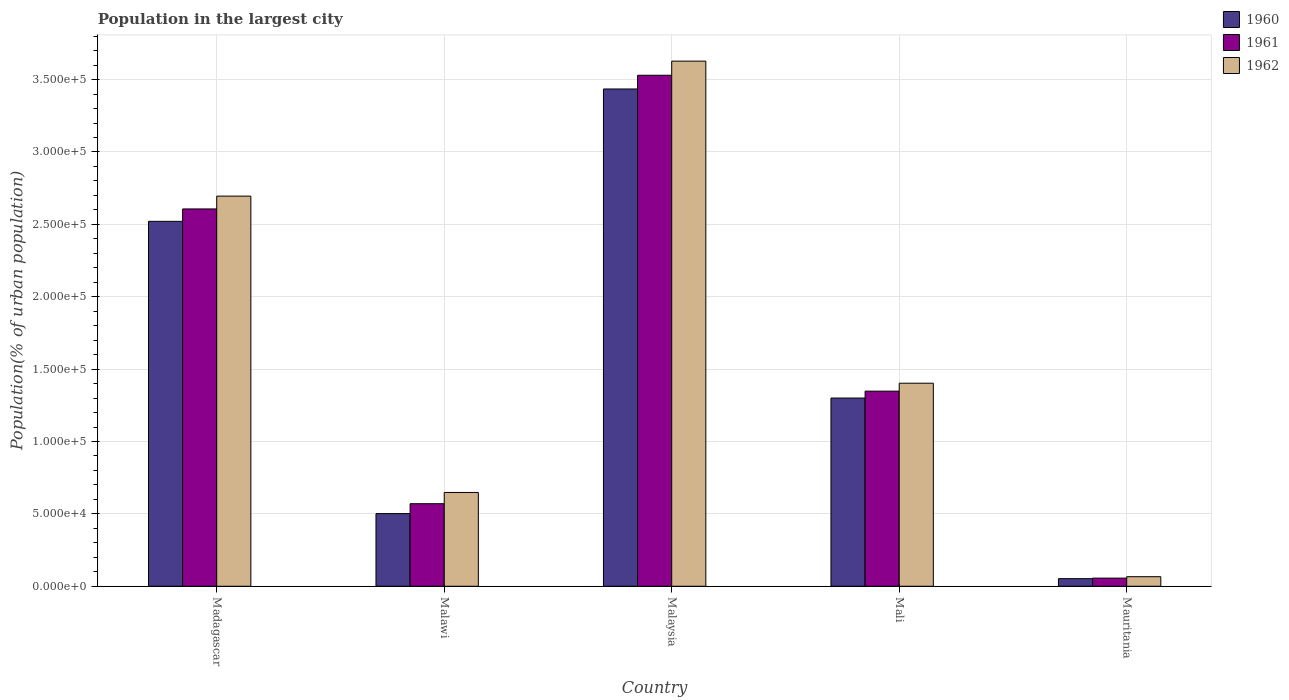Are the number of bars per tick equal to the number of legend labels?
Keep it short and to the point. Yes. Are the number of bars on each tick of the X-axis equal?
Keep it short and to the point. Yes. What is the label of the 5th group of bars from the left?
Your answer should be compact. Mauritania. What is the population in the largest city in 1960 in Madagascar?
Provide a short and direct response. 2.52e+05. Across all countries, what is the maximum population in the largest city in 1962?
Offer a terse response. 3.63e+05. Across all countries, what is the minimum population in the largest city in 1962?
Provide a succinct answer. 6603. In which country was the population in the largest city in 1960 maximum?
Your response must be concise. Malaysia. In which country was the population in the largest city in 1962 minimum?
Ensure brevity in your answer.  Mauritania. What is the total population in the largest city in 1960 in the graph?
Keep it short and to the point. 7.81e+05. What is the difference between the population in the largest city in 1962 in Madagascar and that in Malawi?
Provide a succinct answer. 2.05e+05. What is the difference between the population in the largest city in 1960 in Mauritania and the population in the largest city in 1961 in Mali?
Provide a short and direct response. -1.30e+05. What is the average population in the largest city in 1960 per country?
Keep it short and to the point. 1.56e+05. What is the difference between the population in the largest city of/in 1962 and population in the largest city of/in 1961 in Mauritania?
Your response must be concise. 987. In how many countries, is the population in the largest city in 1962 greater than 350000 %?
Your answer should be compact. 1. What is the ratio of the population in the largest city in 1960 in Mali to that in Mauritania?
Your response must be concise. 24.75. Is the population in the largest city in 1962 in Malaysia less than that in Mauritania?
Offer a very short reply. No. Is the difference between the population in the largest city in 1962 in Mali and Mauritania greater than the difference between the population in the largest city in 1961 in Mali and Mauritania?
Your answer should be compact. Yes. What is the difference between the highest and the second highest population in the largest city in 1961?
Make the answer very short. -1.26e+05. What is the difference between the highest and the lowest population in the largest city in 1962?
Provide a succinct answer. 3.56e+05. In how many countries, is the population in the largest city in 1960 greater than the average population in the largest city in 1960 taken over all countries?
Your answer should be very brief. 2. Is the sum of the population in the largest city in 1960 in Malawi and Mali greater than the maximum population in the largest city in 1962 across all countries?
Your response must be concise. No. What does the 1st bar from the left in Mauritania represents?
Provide a short and direct response. 1960. Is it the case that in every country, the sum of the population in the largest city in 1961 and population in the largest city in 1962 is greater than the population in the largest city in 1960?
Make the answer very short. Yes. How many bars are there?
Give a very brief answer. 15. Are all the bars in the graph horizontal?
Provide a succinct answer. No. How many legend labels are there?
Ensure brevity in your answer.  3. How are the legend labels stacked?
Provide a short and direct response. Vertical. What is the title of the graph?
Offer a terse response. Population in the largest city. Does "1968" appear as one of the legend labels in the graph?
Offer a very short reply. No. What is the label or title of the X-axis?
Give a very brief answer. Country. What is the label or title of the Y-axis?
Your response must be concise. Population(% of urban population). What is the Population(% of urban population) of 1960 in Madagascar?
Offer a very short reply. 2.52e+05. What is the Population(% of urban population) in 1961 in Madagascar?
Offer a very short reply. 2.61e+05. What is the Population(% of urban population) of 1962 in Madagascar?
Provide a succinct answer. 2.70e+05. What is the Population(% of urban population) of 1960 in Malawi?
Your response must be concise. 5.02e+04. What is the Population(% of urban population) in 1961 in Malawi?
Make the answer very short. 5.70e+04. What is the Population(% of urban population) of 1962 in Malawi?
Ensure brevity in your answer.  6.48e+04. What is the Population(% of urban population) in 1960 in Malaysia?
Your answer should be very brief. 3.44e+05. What is the Population(% of urban population) of 1961 in Malaysia?
Offer a very short reply. 3.53e+05. What is the Population(% of urban population) in 1962 in Malaysia?
Keep it short and to the point. 3.63e+05. What is the Population(% of urban population) of 1960 in Mali?
Your response must be concise. 1.30e+05. What is the Population(% of urban population) in 1961 in Mali?
Keep it short and to the point. 1.35e+05. What is the Population(% of urban population) of 1962 in Mali?
Your response must be concise. 1.40e+05. What is the Population(% of urban population) in 1960 in Mauritania?
Ensure brevity in your answer.  5254. What is the Population(% of urban population) of 1961 in Mauritania?
Keep it short and to the point. 5616. What is the Population(% of urban population) of 1962 in Mauritania?
Your answer should be very brief. 6603. Across all countries, what is the maximum Population(% of urban population) in 1960?
Your response must be concise. 3.44e+05. Across all countries, what is the maximum Population(% of urban population) in 1961?
Your response must be concise. 3.53e+05. Across all countries, what is the maximum Population(% of urban population) in 1962?
Your answer should be compact. 3.63e+05. Across all countries, what is the minimum Population(% of urban population) in 1960?
Give a very brief answer. 5254. Across all countries, what is the minimum Population(% of urban population) in 1961?
Your answer should be very brief. 5616. Across all countries, what is the minimum Population(% of urban population) in 1962?
Provide a short and direct response. 6603. What is the total Population(% of urban population) of 1960 in the graph?
Provide a short and direct response. 7.81e+05. What is the total Population(% of urban population) of 1961 in the graph?
Your response must be concise. 8.11e+05. What is the total Population(% of urban population) of 1962 in the graph?
Your answer should be compact. 8.44e+05. What is the difference between the Population(% of urban population) in 1960 in Madagascar and that in Malawi?
Provide a short and direct response. 2.02e+05. What is the difference between the Population(% of urban population) in 1961 in Madagascar and that in Malawi?
Keep it short and to the point. 2.04e+05. What is the difference between the Population(% of urban population) of 1962 in Madagascar and that in Malawi?
Provide a short and direct response. 2.05e+05. What is the difference between the Population(% of urban population) of 1960 in Madagascar and that in Malaysia?
Offer a terse response. -9.14e+04. What is the difference between the Population(% of urban population) of 1961 in Madagascar and that in Malaysia?
Offer a very short reply. -9.24e+04. What is the difference between the Population(% of urban population) in 1962 in Madagascar and that in Malaysia?
Provide a succinct answer. -9.32e+04. What is the difference between the Population(% of urban population) in 1960 in Madagascar and that in Mali?
Give a very brief answer. 1.22e+05. What is the difference between the Population(% of urban population) in 1961 in Madagascar and that in Mali?
Your answer should be compact. 1.26e+05. What is the difference between the Population(% of urban population) in 1962 in Madagascar and that in Mali?
Your answer should be very brief. 1.29e+05. What is the difference between the Population(% of urban population) of 1960 in Madagascar and that in Mauritania?
Offer a very short reply. 2.47e+05. What is the difference between the Population(% of urban population) in 1961 in Madagascar and that in Mauritania?
Provide a succinct answer. 2.55e+05. What is the difference between the Population(% of urban population) of 1962 in Madagascar and that in Mauritania?
Your response must be concise. 2.63e+05. What is the difference between the Population(% of urban population) of 1960 in Malawi and that in Malaysia?
Offer a terse response. -2.93e+05. What is the difference between the Population(% of urban population) in 1961 in Malawi and that in Malaysia?
Ensure brevity in your answer.  -2.96e+05. What is the difference between the Population(% of urban population) of 1962 in Malawi and that in Malaysia?
Keep it short and to the point. -2.98e+05. What is the difference between the Population(% of urban population) of 1960 in Malawi and that in Mali?
Provide a short and direct response. -7.98e+04. What is the difference between the Population(% of urban population) of 1961 in Malawi and that in Mali?
Keep it short and to the point. -7.78e+04. What is the difference between the Population(% of urban population) of 1962 in Malawi and that in Mali?
Offer a terse response. -7.55e+04. What is the difference between the Population(% of urban population) of 1960 in Malawi and that in Mauritania?
Ensure brevity in your answer.  4.49e+04. What is the difference between the Population(% of urban population) of 1961 in Malawi and that in Mauritania?
Provide a short and direct response. 5.14e+04. What is the difference between the Population(% of urban population) of 1962 in Malawi and that in Mauritania?
Offer a terse response. 5.82e+04. What is the difference between the Population(% of urban population) in 1960 in Malaysia and that in Mali?
Provide a short and direct response. 2.14e+05. What is the difference between the Population(% of urban population) of 1961 in Malaysia and that in Mali?
Offer a very short reply. 2.18e+05. What is the difference between the Population(% of urban population) of 1962 in Malaysia and that in Mali?
Provide a short and direct response. 2.23e+05. What is the difference between the Population(% of urban population) in 1960 in Malaysia and that in Mauritania?
Make the answer very short. 3.38e+05. What is the difference between the Population(% of urban population) in 1961 in Malaysia and that in Mauritania?
Ensure brevity in your answer.  3.47e+05. What is the difference between the Population(% of urban population) in 1962 in Malaysia and that in Mauritania?
Your response must be concise. 3.56e+05. What is the difference between the Population(% of urban population) of 1960 in Mali and that in Mauritania?
Offer a very short reply. 1.25e+05. What is the difference between the Population(% of urban population) of 1961 in Mali and that in Mauritania?
Your response must be concise. 1.29e+05. What is the difference between the Population(% of urban population) in 1962 in Mali and that in Mauritania?
Provide a short and direct response. 1.34e+05. What is the difference between the Population(% of urban population) in 1960 in Madagascar and the Population(% of urban population) in 1961 in Malawi?
Keep it short and to the point. 1.95e+05. What is the difference between the Population(% of urban population) of 1960 in Madagascar and the Population(% of urban population) of 1962 in Malawi?
Keep it short and to the point. 1.87e+05. What is the difference between the Population(% of urban population) of 1961 in Madagascar and the Population(% of urban population) of 1962 in Malawi?
Make the answer very short. 1.96e+05. What is the difference between the Population(% of urban population) of 1960 in Madagascar and the Population(% of urban population) of 1961 in Malaysia?
Give a very brief answer. -1.01e+05. What is the difference between the Population(% of urban population) in 1960 in Madagascar and the Population(% of urban population) in 1962 in Malaysia?
Keep it short and to the point. -1.11e+05. What is the difference between the Population(% of urban population) of 1961 in Madagascar and the Population(% of urban population) of 1962 in Malaysia?
Your answer should be very brief. -1.02e+05. What is the difference between the Population(% of urban population) of 1960 in Madagascar and the Population(% of urban population) of 1961 in Mali?
Provide a short and direct response. 1.17e+05. What is the difference between the Population(% of urban population) in 1960 in Madagascar and the Population(% of urban population) in 1962 in Mali?
Your answer should be compact. 1.12e+05. What is the difference between the Population(% of urban population) in 1961 in Madagascar and the Population(% of urban population) in 1962 in Mali?
Offer a terse response. 1.20e+05. What is the difference between the Population(% of urban population) in 1960 in Madagascar and the Population(% of urban population) in 1961 in Mauritania?
Ensure brevity in your answer.  2.46e+05. What is the difference between the Population(% of urban population) of 1960 in Madagascar and the Population(% of urban population) of 1962 in Mauritania?
Your answer should be very brief. 2.45e+05. What is the difference between the Population(% of urban population) in 1961 in Madagascar and the Population(% of urban population) in 1962 in Mauritania?
Provide a succinct answer. 2.54e+05. What is the difference between the Population(% of urban population) of 1960 in Malawi and the Population(% of urban population) of 1961 in Malaysia?
Make the answer very short. -3.03e+05. What is the difference between the Population(% of urban population) of 1960 in Malawi and the Population(% of urban population) of 1962 in Malaysia?
Your answer should be compact. -3.13e+05. What is the difference between the Population(% of urban population) of 1961 in Malawi and the Population(% of urban population) of 1962 in Malaysia?
Offer a terse response. -3.06e+05. What is the difference between the Population(% of urban population) in 1960 in Malawi and the Population(% of urban population) in 1961 in Mali?
Give a very brief answer. -8.46e+04. What is the difference between the Population(% of urban population) of 1960 in Malawi and the Population(% of urban population) of 1962 in Mali?
Give a very brief answer. -9.01e+04. What is the difference between the Population(% of urban population) in 1961 in Malawi and the Population(% of urban population) in 1962 in Mali?
Offer a terse response. -8.32e+04. What is the difference between the Population(% of urban population) of 1960 in Malawi and the Population(% of urban population) of 1961 in Mauritania?
Provide a succinct answer. 4.46e+04. What is the difference between the Population(% of urban population) in 1960 in Malawi and the Population(% of urban population) in 1962 in Mauritania?
Give a very brief answer. 4.36e+04. What is the difference between the Population(% of urban population) of 1961 in Malawi and the Population(% of urban population) of 1962 in Mauritania?
Offer a very short reply. 5.04e+04. What is the difference between the Population(% of urban population) of 1960 in Malaysia and the Population(% of urban population) of 1961 in Mali?
Give a very brief answer. 2.09e+05. What is the difference between the Population(% of urban population) of 1960 in Malaysia and the Population(% of urban population) of 1962 in Mali?
Offer a very short reply. 2.03e+05. What is the difference between the Population(% of urban population) in 1961 in Malaysia and the Population(% of urban population) in 1962 in Mali?
Your answer should be very brief. 2.13e+05. What is the difference between the Population(% of urban population) of 1960 in Malaysia and the Population(% of urban population) of 1961 in Mauritania?
Your response must be concise. 3.38e+05. What is the difference between the Population(% of urban population) in 1960 in Malaysia and the Population(% of urban population) in 1962 in Mauritania?
Make the answer very short. 3.37e+05. What is the difference between the Population(% of urban population) in 1961 in Malaysia and the Population(% of urban population) in 1962 in Mauritania?
Your response must be concise. 3.46e+05. What is the difference between the Population(% of urban population) in 1960 in Mali and the Population(% of urban population) in 1961 in Mauritania?
Keep it short and to the point. 1.24e+05. What is the difference between the Population(% of urban population) of 1960 in Mali and the Population(% of urban population) of 1962 in Mauritania?
Make the answer very short. 1.23e+05. What is the difference between the Population(% of urban population) in 1961 in Mali and the Population(% of urban population) in 1962 in Mauritania?
Your response must be concise. 1.28e+05. What is the average Population(% of urban population) of 1960 per country?
Keep it short and to the point. 1.56e+05. What is the average Population(% of urban population) of 1961 per country?
Keep it short and to the point. 1.62e+05. What is the average Population(% of urban population) in 1962 per country?
Your answer should be very brief. 1.69e+05. What is the difference between the Population(% of urban population) in 1960 and Population(% of urban population) in 1961 in Madagascar?
Provide a succinct answer. -8560. What is the difference between the Population(% of urban population) of 1960 and Population(% of urban population) of 1962 in Madagascar?
Your answer should be very brief. -1.74e+04. What is the difference between the Population(% of urban population) in 1961 and Population(% of urban population) in 1962 in Madagascar?
Your answer should be compact. -8864. What is the difference between the Population(% of urban population) of 1960 and Population(% of urban population) of 1961 in Malawi?
Offer a terse response. -6827. What is the difference between the Population(% of urban population) in 1960 and Population(% of urban population) in 1962 in Malawi?
Your answer should be compact. -1.46e+04. What is the difference between the Population(% of urban population) of 1961 and Population(% of urban population) of 1962 in Malawi?
Make the answer very short. -7766. What is the difference between the Population(% of urban population) of 1960 and Population(% of urban population) of 1961 in Malaysia?
Offer a terse response. -9483. What is the difference between the Population(% of urban population) of 1960 and Population(% of urban population) of 1962 in Malaysia?
Your answer should be compact. -1.92e+04. What is the difference between the Population(% of urban population) in 1961 and Population(% of urban population) in 1962 in Malaysia?
Your answer should be very brief. -9758. What is the difference between the Population(% of urban population) of 1960 and Population(% of urban population) of 1961 in Mali?
Provide a succinct answer. -4767. What is the difference between the Population(% of urban population) in 1960 and Population(% of urban population) in 1962 in Mali?
Keep it short and to the point. -1.02e+04. What is the difference between the Population(% of urban population) of 1961 and Population(% of urban population) of 1962 in Mali?
Ensure brevity in your answer.  -5483. What is the difference between the Population(% of urban population) in 1960 and Population(% of urban population) in 1961 in Mauritania?
Your answer should be compact. -362. What is the difference between the Population(% of urban population) of 1960 and Population(% of urban population) of 1962 in Mauritania?
Your answer should be compact. -1349. What is the difference between the Population(% of urban population) of 1961 and Population(% of urban population) of 1962 in Mauritania?
Your response must be concise. -987. What is the ratio of the Population(% of urban population) of 1960 in Madagascar to that in Malawi?
Ensure brevity in your answer.  5.02. What is the ratio of the Population(% of urban population) in 1961 in Madagascar to that in Malawi?
Make the answer very short. 4.57. What is the ratio of the Population(% of urban population) of 1962 in Madagascar to that in Malawi?
Offer a terse response. 4.16. What is the ratio of the Population(% of urban population) in 1960 in Madagascar to that in Malaysia?
Offer a very short reply. 0.73. What is the ratio of the Population(% of urban population) in 1961 in Madagascar to that in Malaysia?
Your answer should be very brief. 0.74. What is the ratio of the Population(% of urban population) of 1962 in Madagascar to that in Malaysia?
Ensure brevity in your answer.  0.74. What is the ratio of the Population(% of urban population) in 1960 in Madagascar to that in Mali?
Keep it short and to the point. 1.94. What is the ratio of the Population(% of urban population) in 1961 in Madagascar to that in Mali?
Provide a short and direct response. 1.93. What is the ratio of the Population(% of urban population) of 1962 in Madagascar to that in Mali?
Your response must be concise. 1.92. What is the ratio of the Population(% of urban population) of 1960 in Madagascar to that in Mauritania?
Your response must be concise. 47.98. What is the ratio of the Population(% of urban population) of 1961 in Madagascar to that in Mauritania?
Keep it short and to the point. 46.41. What is the ratio of the Population(% of urban population) of 1962 in Madagascar to that in Mauritania?
Your response must be concise. 40.82. What is the ratio of the Population(% of urban population) of 1960 in Malawi to that in Malaysia?
Ensure brevity in your answer.  0.15. What is the ratio of the Population(% of urban population) of 1961 in Malawi to that in Malaysia?
Your answer should be very brief. 0.16. What is the ratio of the Population(% of urban population) in 1962 in Malawi to that in Malaysia?
Provide a short and direct response. 0.18. What is the ratio of the Population(% of urban population) in 1960 in Malawi to that in Mali?
Your response must be concise. 0.39. What is the ratio of the Population(% of urban population) in 1961 in Malawi to that in Mali?
Keep it short and to the point. 0.42. What is the ratio of the Population(% of urban population) in 1962 in Malawi to that in Mali?
Offer a very short reply. 0.46. What is the ratio of the Population(% of urban population) in 1960 in Malawi to that in Mauritania?
Offer a very short reply. 9.55. What is the ratio of the Population(% of urban population) in 1961 in Malawi to that in Mauritania?
Provide a succinct answer. 10.15. What is the ratio of the Population(% of urban population) of 1962 in Malawi to that in Mauritania?
Your answer should be very brief. 9.81. What is the ratio of the Population(% of urban population) of 1960 in Malaysia to that in Mali?
Your answer should be very brief. 2.64. What is the ratio of the Population(% of urban population) in 1961 in Malaysia to that in Mali?
Ensure brevity in your answer.  2.62. What is the ratio of the Population(% of urban population) in 1962 in Malaysia to that in Mali?
Provide a short and direct response. 2.59. What is the ratio of the Population(% of urban population) of 1960 in Malaysia to that in Mauritania?
Offer a terse response. 65.38. What is the ratio of the Population(% of urban population) in 1961 in Malaysia to that in Mauritania?
Give a very brief answer. 62.86. What is the ratio of the Population(% of urban population) in 1962 in Malaysia to that in Mauritania?
Keep it short and to the point. 54.94. What is the ratio of the Population(% of urban population) of 1960 in Mali to that in Mauritania?
Keep it short and to the point. 24.75. What is the ratio of the Population(% of urban population) in 1961 in Mali to that in Mauritania?
Your response must be concise. 24. What is the ratio of the Population(% of urban population) of 1962 in Mali to that in Mauritania?
Give a very brief answer. 21.24. What is the difference between the highest and the second highest Population(% of urban population) of 1960?
Keep it short and to the point. 9.14e+04. What is the difference between the highest and the second highest Population(% of urban population) in 1961?
Make the answer very short. 9.24e+04. What is the difference between the highest and the second highest Population(% of urban population) of 1962?
Offer a very short reply. 9.32e+04. What is the difference between the highest and the lowest Population(% of urban population) of 1960?
Provide a short and direct response. 3.38e+05. What is the difference between the highest and the lowest Population(% of urban population) of 1961?
Your answer should be compact. 3.47e+05. What is the difference between the highest and the lowest Population(% of urban population) in 1962?
Provide a succinct answer. 3.56e+05. 